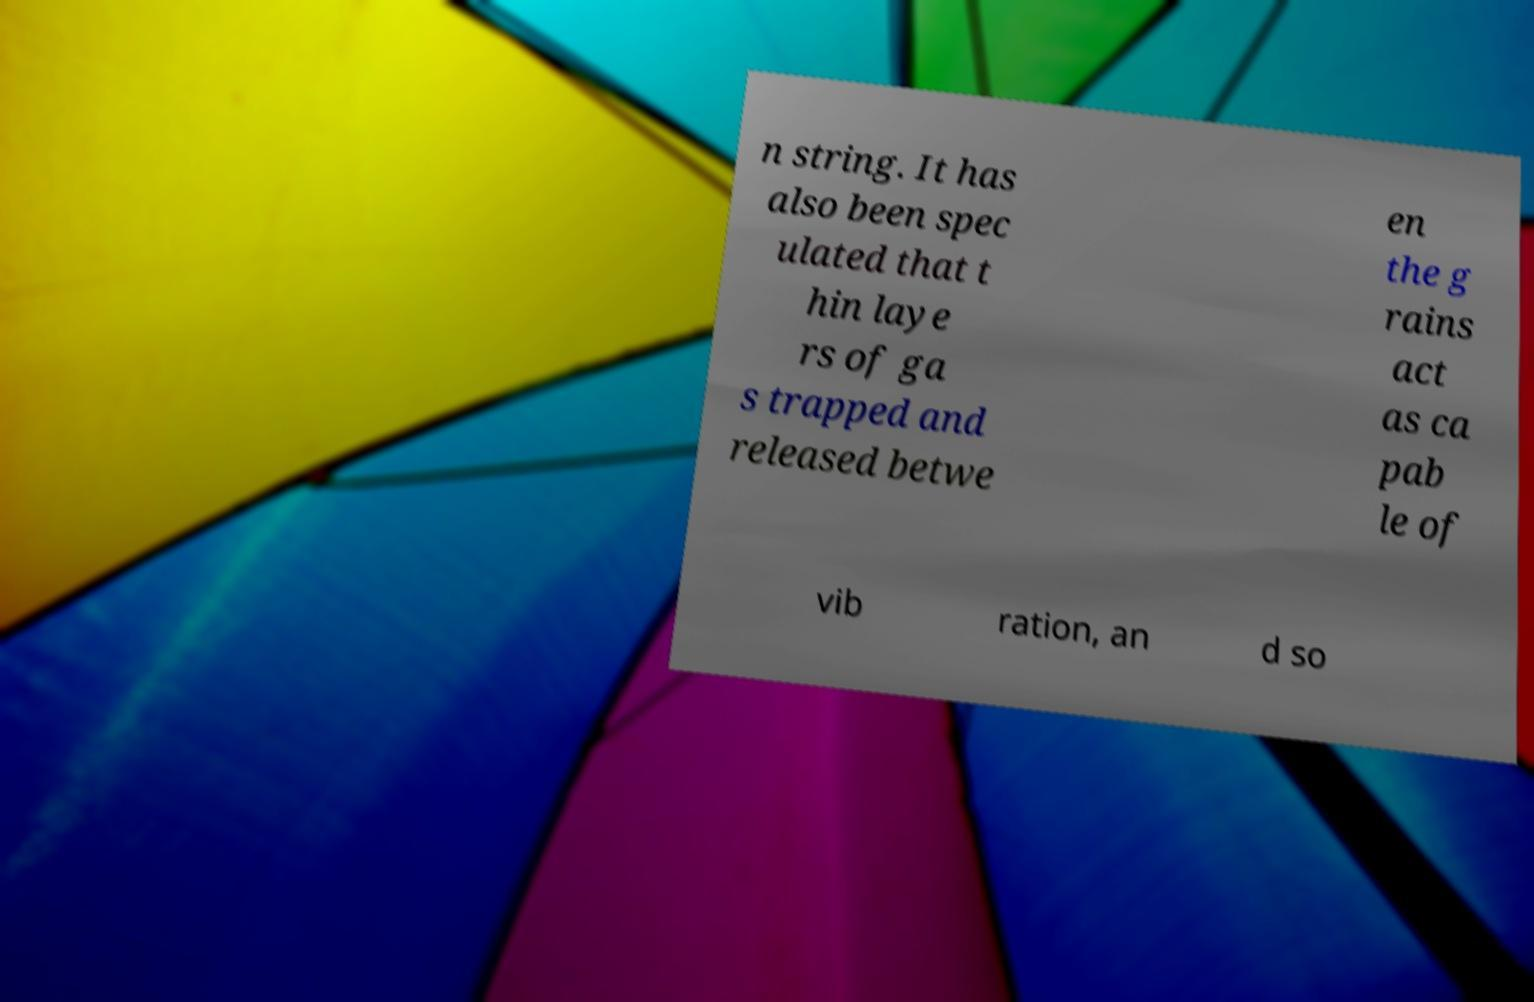For documentation purposes, I need the text within this image transcribed. Could you provide that? n string. It has also been spec ulated that t hin laye rs of ga s trapped and released betwe en the g rains act as ca pab le of vib ration, an d so 